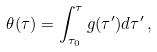<formula> <loc_0><loc_0><loc_500><loc_500>\theta ( \tau ) = \int ^ { \tau } _ { \tau _ { 0 } } g ( \tau ^ { \prime } ) d \tau ^ { \prime } \, ,</formula> 